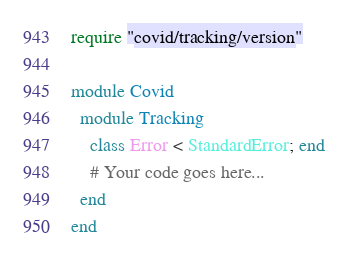Convert code to text. <code><loc_0><loc_0><loc_500><loc_500><_Ruby_>require "covid/tracking/version"

module Covid
  module Tracking
    class Error < StandardError; end
    # Your code goes here...
  end
end
</code> 